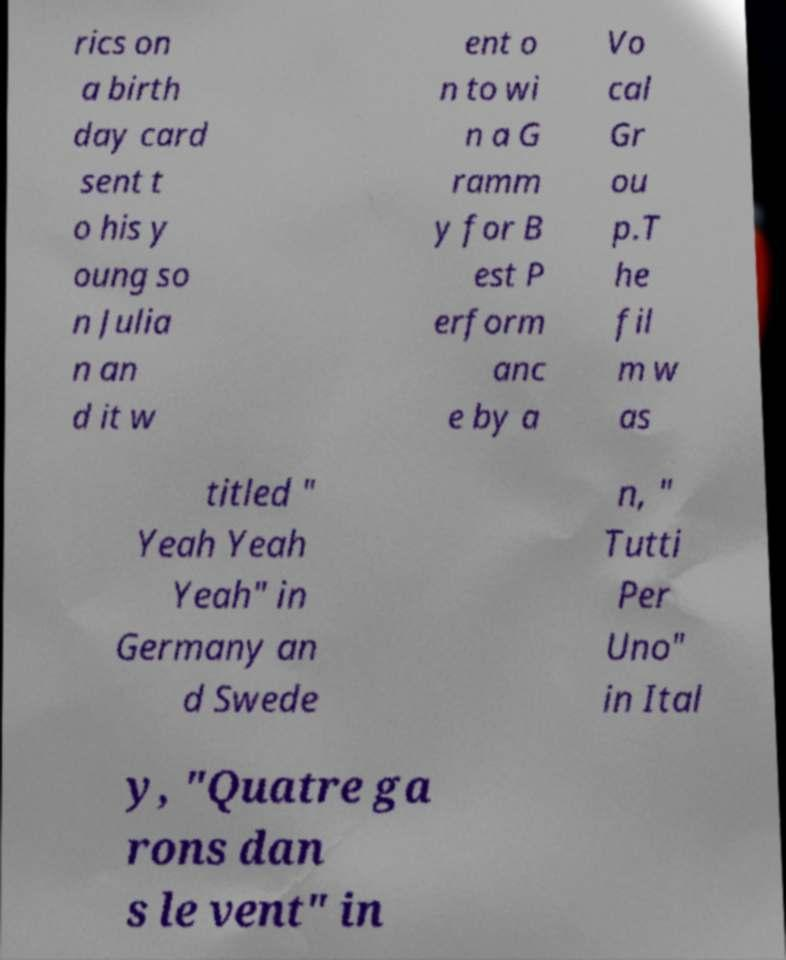Please identify and transcribe the text found in this image. rics on a birth day card sent t o his y oung so n Julia n an d it w ent o n to wi n a G ramm y for B est P erform anc e by a Vo cal Gr ou p.T he fil m w as titled " Yeah Yeah Yeah" in Germany an d Swede n, " Tutti Per Uno" in Ital y, "Quatre ga rons dan s le vent" in 